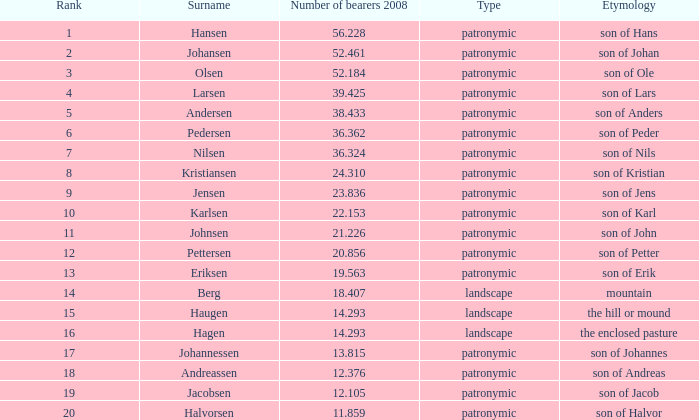What is Type, when Rank is greater than 6, when Number of Bearers 2008 is greater than 13.815, and when Surname is Eriksen? Patronymic. 